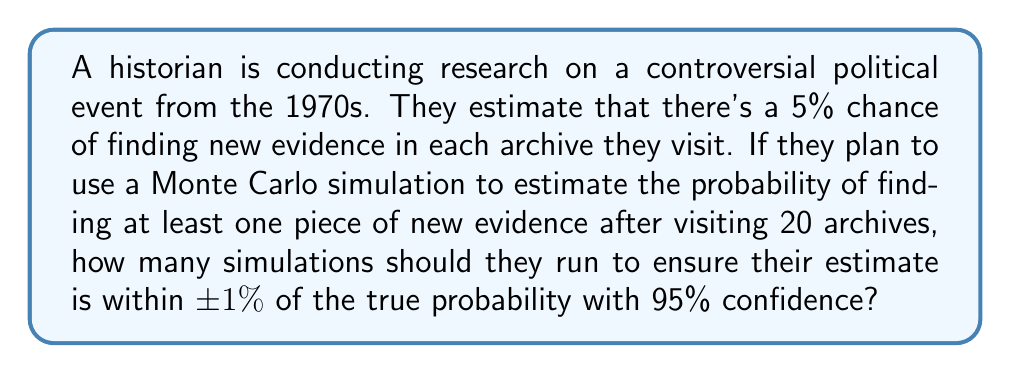Can you answer this question? Let's approach this step-by-step:

1) First, we need to calculate the true probability of finding at least one piece of new evidence after visiting 20 archives:

   $P(\text{at least one}) = 1 - P(\text{none})$
   $= 1 - (0.95)^{20} \approx 0.6415$ or 64.15%

2) Now, we need to determine the sample size (number of simulations) needed for our estimate to be within ±1% of this true probability with 95% confidence.

3) For this, we can use the formula for sample size calculation in a proportion estimate:

   $n = \frac{z^2 \cdot p(1-p)}{E^2}$

   Where:
   $n$ = number of simulations
   $z$ = z-score for 95% confidence level (1.96)
   $p$ = true probability (0.6415)
   $E$ = margin of error (0.01)

4) Plugging in the values:

   $n = \frac{1.96^2 \cdot 0.6415(1-0.6415)}{0.01^2}$

5) Calculating:

   $n = \frac{3.8416 \cdot 0.6415 \cdot 0.3585}{0.0001}$
   $n = 8,834.8$

6) Since we can't run a fractional number of simulations, we round up to the nearest whole number.
Answer: 8,835 simulations 